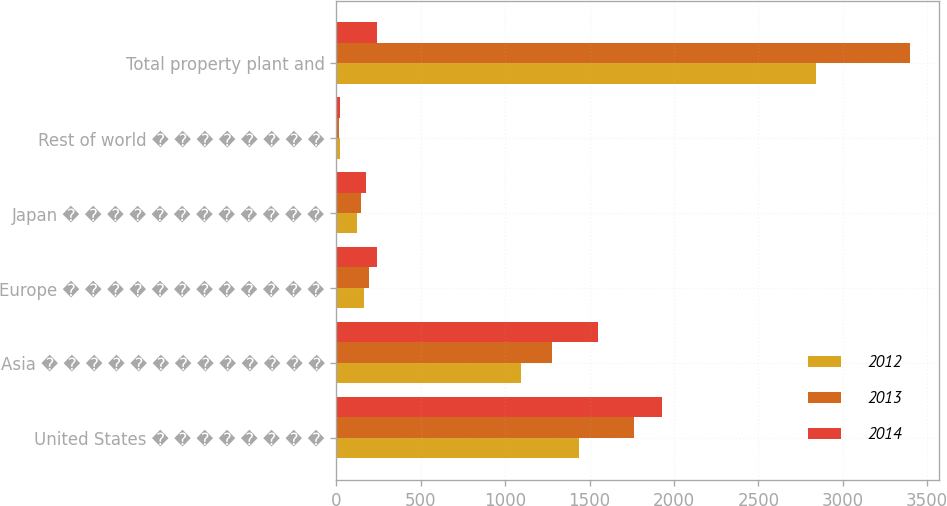Convert chart. <chart><loc_0><loc_0><loc_500><loc_500><stacked_bar_chart><ecel><fcel>United States � � � � � � � �<fcel>Asia � � � � � � � � � � � � �<fcel>Europe � � � � � � � � � � � �<fcel>Japan � � � � � � � � � � � �<fcel>Rest of world � � � � � � � �<fcel>Total property plant and<nl><fcel>2012<fcel>1436<fcel>1096<fcel>162<fcel>124<fcel>22<fcel>2840<nl><fcel>2013<fcel>1765<fcel>1277<fcel>196<fcel>144<fcel>17<fcel>3399<nl><fcel>2014<fcel>1931<fcel>1547<fcel>241<fcel>174<fcel>19<fcel>241<nl></chart> 